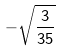Convert formula to latex. <formula><loc_0><loc_0><loc_500><loc_500>- \sqrt { \frac { 3 } { 3 5 } }</formula> 